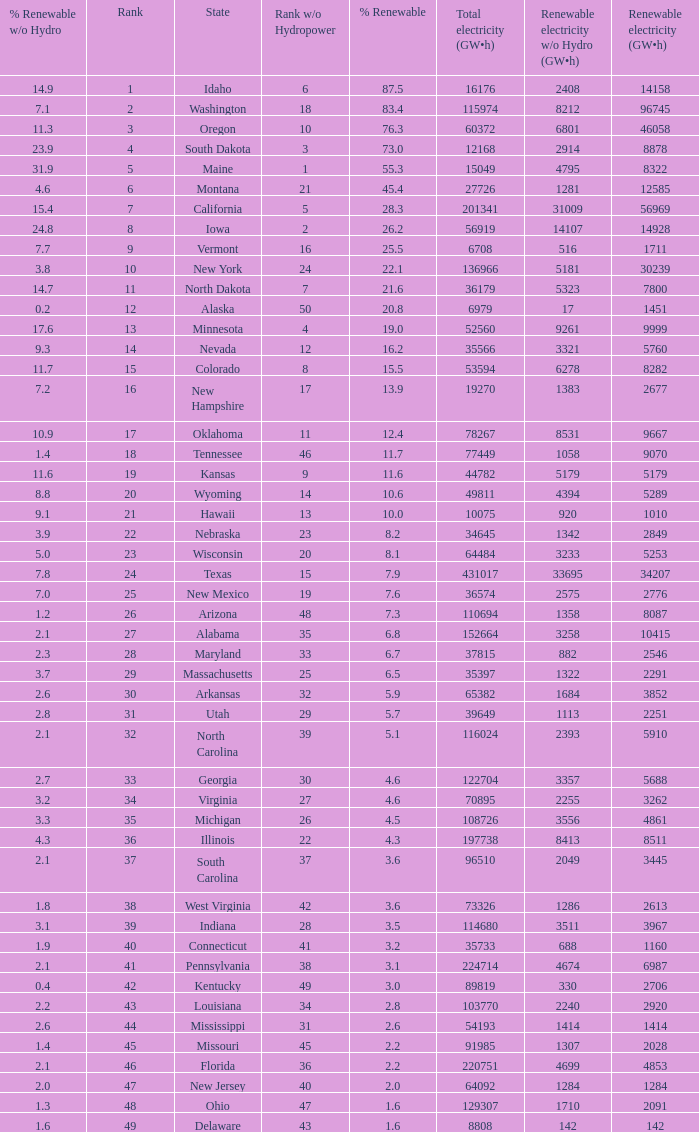Parse the table in full. {'header': ['% Renewable w/o Hydro', 'Rank', 'State', 'Rank w/o Hydropower', '% Renewable', 'Total electricity (GW•h)', 'Renewable electricity w/o Hydro (GW•h)', 'Renewable electricity (GW•h)'], 'rows': [['14.9', '1', 'Idaho', '6', '87.5', '16176', '2408', '14158'], ['7.1', '2', 'Washington', '18', '83.4', '115974', '8212', '96745'], ['11.3', '3', 'Oregon', '10', '76.3', '60372', '6801', '46058'], ['23.9', '4', 'South Dakota', '3', '73.0', '12168', '2914', '8878'], ['31.9', '5', 'Maine', '1', '55.3', '15049', '4795', '8322'], ['4.6', '6', 'Montana', '21', '45.4', '27726', '1281', '12585'], ['15.4', '7', 'California', '5', '28.3', '201341', '31009', '56969'], ['24.8', '8', 'Iowa', '2', '26.2', '56919', '14107', '14928'], ['7.7', '9', 'Vermont', '16', '25.5', '6708', '516', '1711'], ['3.8', '10', 'New York', '24', '22.1', '136966', '5181', '30239'], ['14.7', '11', 'North Dakota', '7', '21.6', '36179', '5323', '7800'], ['0.2', '12', 'Alaska', '50', '20.8', '6979', '17', '1451'], ['17.6', '13', 'Minnesota', '4', '19.0', '52560', '9261', '9999'], ['9.3', '14', 'Nevada', '12', '16.2', '35566', '3321', '5760'], ['11.7', '15', 'Colorado', '8', '15.5', '53594', '6278', '8282'], ['7.2', '16', 'New Hampshire', '17', '13.9', '19270', '1383', '2677'], ['10.9', '17', 'Oklahoma', '11', '12.4', '78267', '8531', '9667'], ['1.4', '18', 'Tennessee', '46', '11.7', '77449', '1058', '9070'], ['11.6', '19', 'Kansas', '9', '11.6', '44782', '5179', '5179'], ['8.8', '20', 'Wyoming', '14', '10.6', '49811', '4394', '5289'], ['9.1', '21', 'Hawaii', '13', '10.0', '10075', '920', '1010'], ['3.9', '22', 'Nebraska', '23', '8.2', '34645', '1342', '2849'], ['5.0', '23', 'Wisconsin', '20', '8.1', '64484', '3233', '5253'], ['7.8', '24', 'Texas', '15', '7.9', '431017', '33695', '34207'], ['7.0', '25', 'New Mexico', '19', '7.6', '36574', '2575', '2776'], ['1.2', '26', 'Arizona', '48', '7.3', '110694', '1358', '8087'], ['2.1', '27', 'Alabama', '35', '6.8', '152664', '3258', '10415'], ['2.3', '28', 'Maryland', '33', '6.7', '37815', '882', '2546'], ['3.7', '29', 'Massachusetts', '25', '6.5', '35397', '1322', '2291'], ['2.6', '30', 'Arkansas', '32', '5.9', '65382', '1684', '3852'], ['2.8', '31', 'Utah', '29', '5.7', '39649', '1113', '2251'], ['2.1', '32', 'North Carolina', '39', '5.1', '116024', '2393', '5910'], ['2.7', '33', 'Georgia', '30', '4.6', '122704', '3357', '5688'], ['3.2', '34', 'Virginia', '27', '4.6', '70895', '2255', '3262'], ['3.3', '35', 'Michigan', '26', '4.5', '108726', '3556', '4861'], ['4.3', '36', 'Illinois', '22', '4.3', '197738', '8413', '8511'], ['2.1', '37', 'South Carolina', '37', '3.6', '96510', '2049', '3445'], ['1.8', '38', 'West Virginia', '42', '3.6', '73326', '1286', '2613'], ['3.1', '39', 'Indiana', '28', '3.5', '114680', '3511', '3967'], ['1.9', '40', 'Connecticut', '41', '3.2', '35733', '688', '1160'], ['2.1', '41', 'Pennsylvania', '38', '3.1', '224714', '4674', '6987'], ['0.4', '42', 'Kentucky', '49', '3.0', '89819', '330', '2706'], ['2.2', '43', 'Louisiana', '34', '2.8', '103770', '2240', '2920'], ['2.6', '44', 'Mississippi', '31', '2.6', '54193', '1414', '1414'], ['1.4', '45', 'Missouri', '45', '2.2', '91985', '1307', '2028'], ['2.1', '46', 'Florida', '36', '2.2', '220751', '4699', '4853'], ['2.0', '47', 'New Jersey', '40', '2.0', '64092', '1284', '1284'], ['1.3', '48', 'Ohio', '47', '1.6', '129307', '1710', '2091'], ['1.6', '49', 'Delaware', '43', '1.6', '8808', '142', '142']]} What is the amount of renewable electricity without hydrogen power when the percentage of renewable energy is 83.4? 8212.0. 